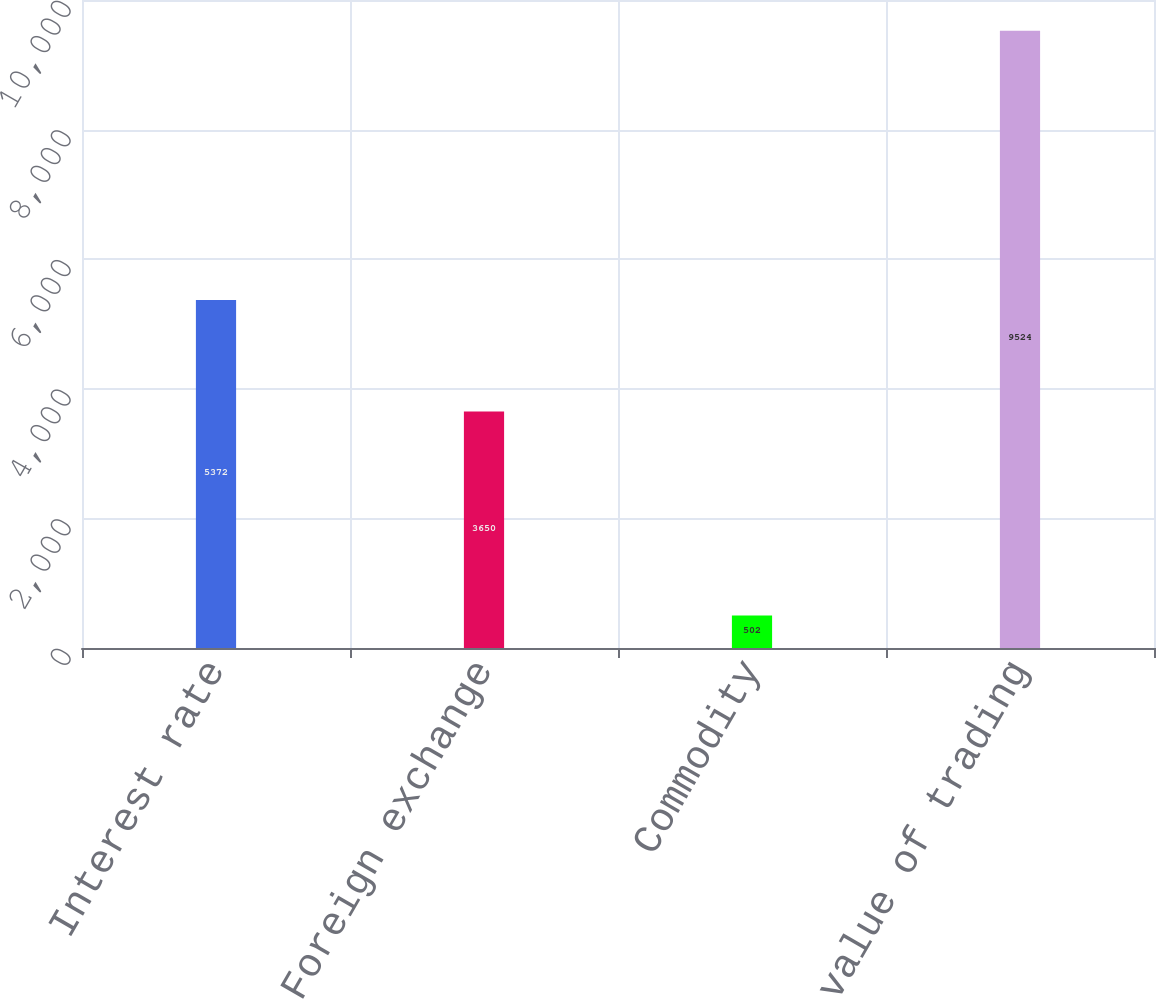Convert chart to OTSL. <chart><loc_0><loc_0><loc_500><loc_500><bar_chart><fcel>Interest rate<fcel>Foreign exchange<fcel>Commodity<fcel>Total fair value of trading<nl><fcel>5372<fcel>3650<fcel>502<fcel>9524<nl></chart> 